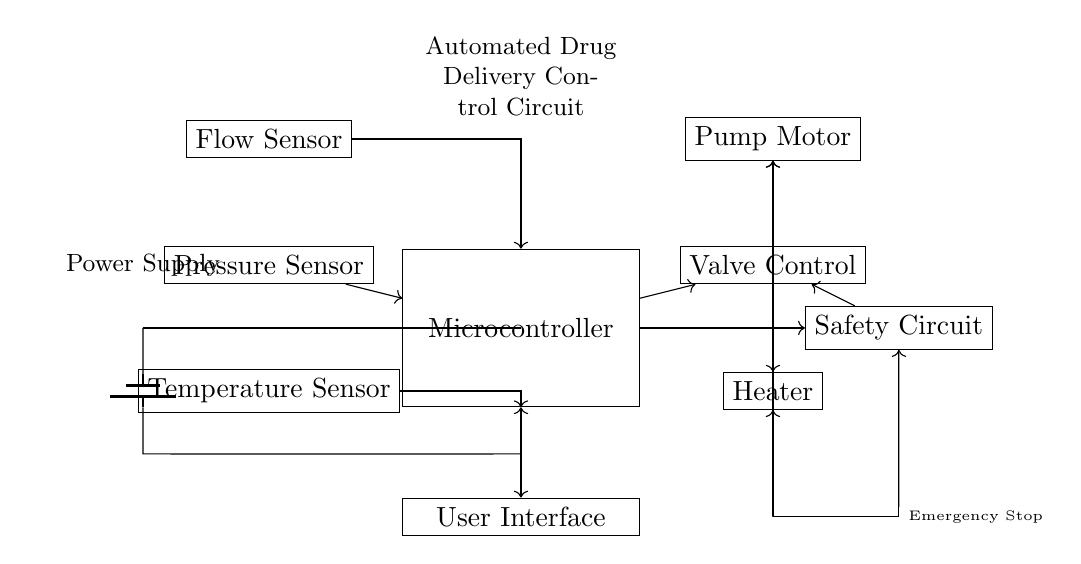What is the main control unit in the circuit? The main control unit is the Microcontroller, which is indicated in the circuit diagram as a rectangle labeled "Microcontroller." It coordinates signals between sensors and actuators.
Answer: Microcontroller How many sensors are depicted in this circuit? The circuit diagram shows three sensors: Flow Sensor, Pressure Sensor, and Temperature Sensor. Each is represented in the diagram as a rectangle labeled accordingly.
Answer: Three What does the User Interface do? The User Interface provides a means for users to interact with the system, allowing for adjustments and monitoring. In the diagram, it connects with the Microcontroller for bi-directional communication.
Answer: Interaction What does the Safety Circuit connect to? The Safety Circuit connects to the Microcontroller and all actuators, which ensures safe operation by controlling the actions based on information from the MCU. This includes interactions with the Pump Motor, Valve Control, and Heater.
Answer: All actuators Which component takes input from the Flow Sensor? The input from the Flow Sensor is directed to the Microcontroller, as shown by the connection (arrow) pointing towards the Microcontroller from the Flow Sensor. This means the MCU will process the flow data.
Answer: Microcontroller What is the purpose of the Emergency Stop? The Emergency Stop is designed to halt the operation of the entire system immediately in case of a critical issue, interacting with the Safety Circuit, as seen by the connection to the Safety Circuit in the diagram.
Answer: Immediate halt How is the power supplied to the circuit? The power is supplied by a battery, as illustrated by the symbols and connections leading from the battery to the Microcontroller and the rest of the circuitry. The battery is located on the left side of the diagram.
Answer: Battery 